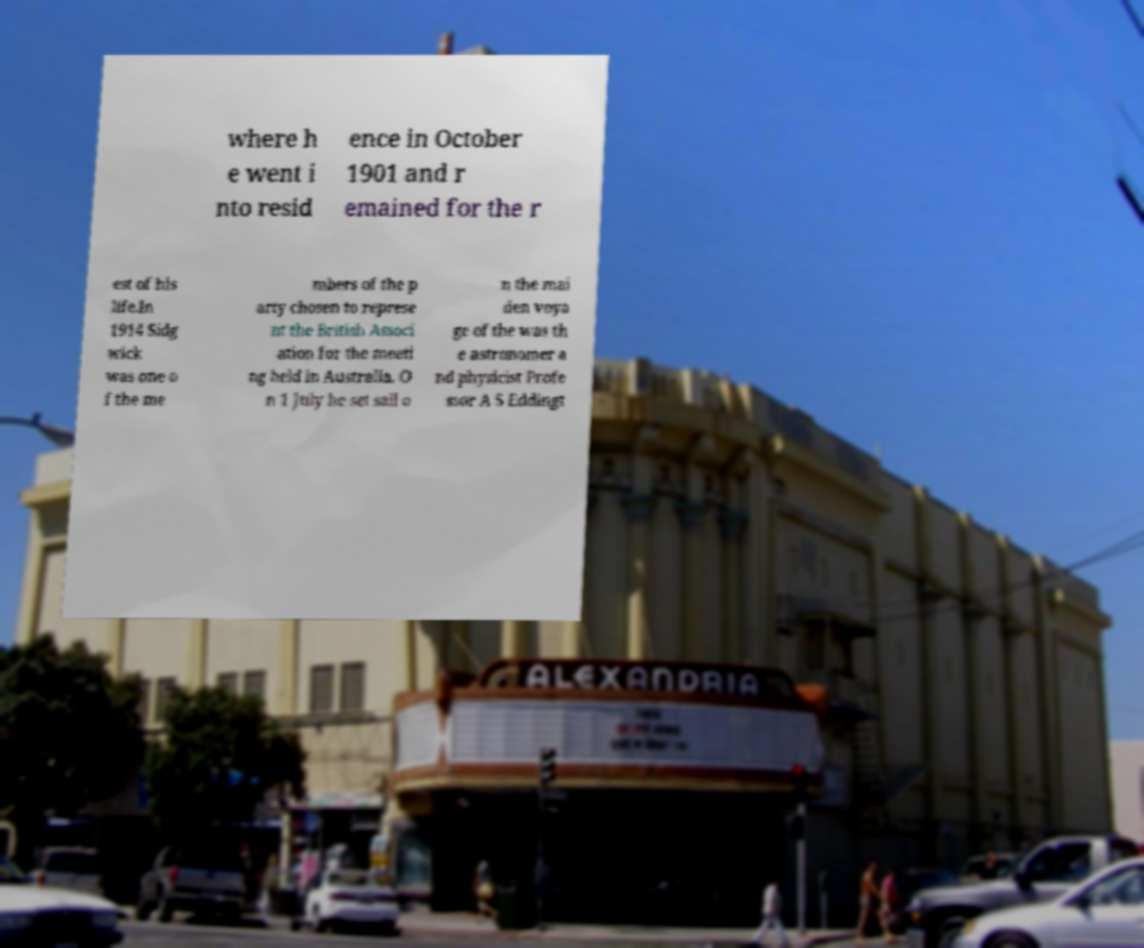Can you read and provide the text displayed in the image?This photo seems to have some interesting text. Can you extract and type it out for me? where h e went i nto resid ence in October 1901 and r emained for the r est of his life.In 1914 Sidg wick was one o f the me mbers of the p arty chosen to represe nt the British Associ ation for the meeti ng held in Australia. O n 1 July he set sail o n the mai den voya ge of the was th e astronomer a nd physicist Profe ssor A S Eddingt 